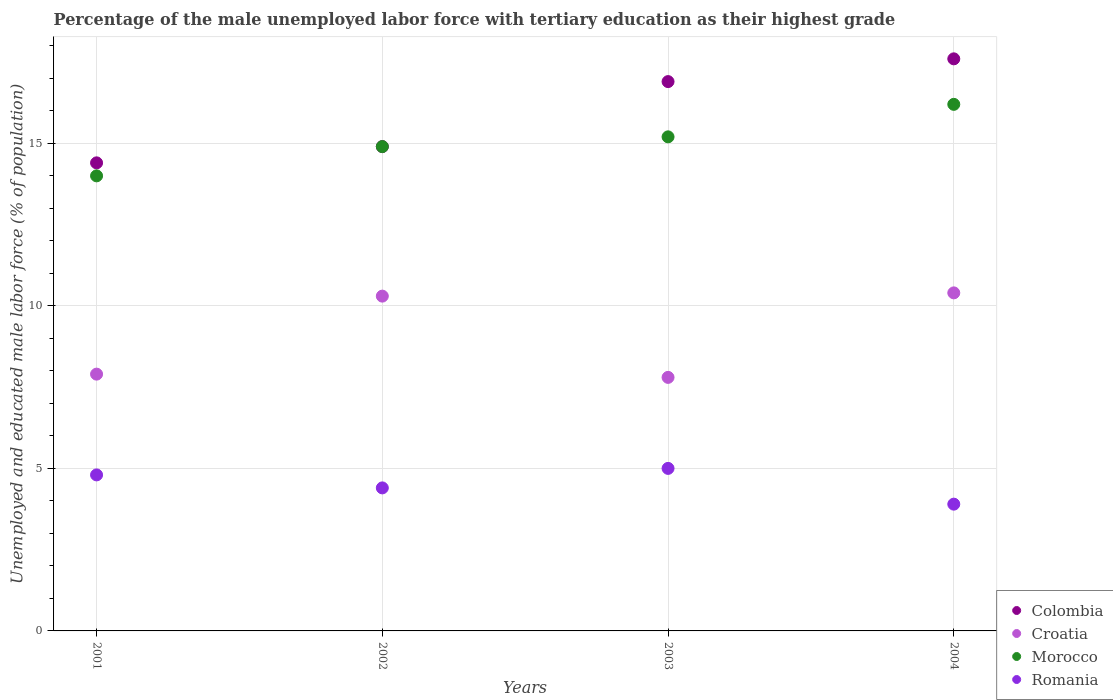Is the number of dotlines equal to the number of legend labels?
Give a very brief answer. Yes. What is the percentage of the unemployed male labor force with tertiary education in Morocco in 2001?
Ensure brevity in your answer.  14. Across all years, what is the maximum percentage of the unemployed male labor force with tertiary education in Colombia?
Give a very brief answer. 17.6. Across all years, what is the minimum percentage of the unemployed male labor force with tertiary education in Romania?
Your response must be concise. 3.9. What is the total percentage of the unemployed male labor force with tertiary education in Morocco in the graph?
Your response must be concise. 60.3. What is the difference between the percentage of the unemployed male labor force with tertiary education in Colombia in 2002 and that in 2004?
Provide a succinct answer. -2.7. What is the difference between the percentage of the unemployed male labor force with tertiary education in Morocco in 2002 and the percentage of the unemployed male labor force with tertiary education in Croatia in 2003?
Your answer should be very brief. 7.1. What is the average percentage of the unemployed male labor force with tertiary education in Romania per year?
Offer a very short reply. 4.53. In the year 2002, what is the difference between the percentage of the unemployed male labor force with tertiary education in Colombia and percentage of the unemployed male labor force with tertiary education in Croatia?
Give a very brief answer. 4.6. In how many years, is the percentage of the unemployed male labor force with tertiary education in Colombia greater than 11 %?
Your response must be concise. 4. What is the ratio of the percentage of the unemployed male labor force with tertiary education in Colombia in 2001 to that in 2003?
Make the answer very short. 0.85. Is the percentage of the unemployed male labor force with tertiary education in Morocco in 2001 less than that in 2002?
Provide a short and direct response. Yes. What is the difference between the highest and the second highest percentage of the unemployed male labor force with tertiary education in Romania?
Your response must be concise. 0.2. What is the difference between the highest and the lowest percentage of the unemployed male labor force with tertiary education in Colombia?
Ensure brevity in your answer.  3.2. In how many years, is the percentage of the unemployed male labor force with tertiary education in Colombia greater than the average percentage of the unemployed male labor force with tertiary education in Colombia taken over all years?
Provide a succinct answer. 2. Is it the case that in every year, the sum of the percentage of the unemployed male labor force with tertiary education in Colombia and percentage of the unemployed male labor force with tertiary education in Morocco  is greater than the sum of percentage of the unemployed male labor force with tertiary education in Croatia and percentage of the unemployed male labor force with tertiary education in Romania?
Ensure brevity in your answer.  Yes. How many dotlines are there?
Provide a short and direct response. 4. How many years are there in the graph?
Provide a short and direct response. 4. Does the graph contain any zero values?
Your answer should be very brief. No. Where does the legend appear in the graph?
Provide a succinct answer. Bottom right. How are the legend labels stacked?
Your response must be concise. Vertical. What is the title of the graph?
Keep it short and to the point. Percentage of the male unemployed labor force with tertiary education as their highest grade. What is the label or title of the Y-axis?
Your answer should be very brief. Unemployed and educated male labor force (% of population). What is the Unemployed and educated male labor force (% of population) of Colombia in 2001?
Your answer should be very brief. 14.4. What is the Unemployed and educated male labor force (% of population) of Croatia in 2001?
Provide a short and direct response. 7.9. What is the Unemployed and educated male labor force (% of population) of Morocco in 2001?
Provide a succinct answer. 14. What is the Unemployed and educated male labor force (% of population) of Romania in 2001?
Offer a terse response. 4.8. What is the Unemployed and educated male labor force (% of population) of Colombia in 2002?
Keep it short and to the point. 14.9. What is the Unemployed and educated male labor force (% of population) in Croatia in 2002?
Provide a succinct answer. 10.3. What is the Unemployed and educated male labor force (% of population) of Morocco in 2002?
Provide a succinct answer. 14.9. What is the Unemployed and educated male labor force (% of population) in Romania in 2002?
Offer a terse response. 4.4. What is the Unemployed and educated male labor force (% of population) of Colombia in 2003?
Your answer should be very brief. 16.9. What is the Unemployed and educated male labor force (% of population) of Croatia in 2003?
Give a very brief answer. 7.8. What is the Unemployed and educated male labor force (% of population) in Morocco in 2003?
Make the answer very short. 15.2. What is the Unemployed and educated male labor force (% of population) in Romania in 2003?
Offer a very short reply. 5. What is the Unemployed and educated male labor force (% of population) in Colombia in 2004?
Your answer should be very brief. 17.6. What is the Unemployed and educated male labor force (% of population) in Croatia in 2004?
Your answer should be compact. 10.4. What is the Unemployed and educated male labor force (% of population) of Morocco in 2004?
Give a very brief answer. 16.2. What is the Unemployed and educated male labor force (% of population) in Romania in 2004?
Ensure brevity in your answer.  3.9. Across all years, what is the maximum Unemployed and educated male labor force (% of population) of Colombia?
Your response must be concise. 17.6. Across all years, what is the maximum Unemployed and educated male labor force (% of population) in Croatia?
Provide a short and direct response. 10.4. Across all years, what is the maximum Unemployed and educated male labor force (% of population) in Morocco?
Keep it short and to the point. 16.2. Across all years, what is the maximum Unemployed and educated male labor force (% of population) of Romania?
Your answer should be very brief. 5. Across all years, what is the minimum Unemployed and educated male labor force (% of population) in Colombia?
Ensure brevity in your answer.  14.4. Across all years, what is the minimum Unemployed and educated male labor force (% of population) of Croatia?
Give a very brief answer. 7.8. Across all years, what is the minimum Unemployed and educated male labor force (% of population) of Morocco?
Keep it short and to the point. 14. Across all years, what is the minimum Unemployed and educated male labor force (% of population) of Romania?
Keep it short and to the point. 3.9. What is the total Unemployed and educated male labor force (% of population) in Colombia in the graph?
Give a very brief answer. 63.8. What is the total Unemployed and educated male labor force (% of population) of Croatia in the graph?
Your response must be concise. 36.4. What is the total Unemployed and educated male labor force (% of population) in Morocco in the graph?
Give a very brief answer. 60.3. What is the difference between the Unemployed and educated male labor force (% of population) in Morocco in 2001 and that in 2002?
Make the answer very short. -0.9. What is the difference between the Unemployed and educated male labor force (% of population) in Colombia in 2001 and that in 2003?
Give a very brief answer. -2.5. What is the difference between the Unemployed and educated male labor force (% of population) in Morocco in 2001 and that in 2003?
Give a very brief answer. -1.2. What is the difference between the Unemployed and educated male labor force (% of population) of Romania in 2001 and that in 2003?
Ensure brevity in your answer.  -0.2. What is the difference between the Unemployed and educated male labor force (% of population) in Colombia in 2001 and that in 2004?
Ensure brevity in your answer.  -3.2. What is the difference between the Unemployed and educated male labor force (% of population) of Croatia in 2001 and that in 2004?
Keep it short and to the point. -2.5. What is the difference between the Unemployed and educated male labor force (% of population) of Romania in 2001 and that in 2004?
Your response must be concise. 0.9. What is the difference between the Unemployed and educated male labor force (% of population) of Colombia in 2002 and that in 2003?
Offer a very short reply. -2. What is the difference between the Unemployed and educated male labor force (% of population) of Romania in 2002 and that in 2003?
Keep it short and to the point. -0.6. What is the difference between the Unemployed and educated male labor force (% of population) in Colombia in 2002 and that in 2004?
Give a very brief answer. -2.7. What is the difference between the Unemployed and educated male labor force (% of population) in Croatia in 2003 and that in 2004?
Ensure brevity in your answer.  -2.6. What is the difference between the Unemployed and educated male labor force (% of population) of Morocco in 2003 and that in 2004?
Offer a terse response. -1. What is the difference between the Unemployed and educated male labor force (% of population) of Romania in 2003 and that in 2004?
Your answer should be very brief. 1.1. What is the difference between the Unemployed and educated male labor force (% of population) of Colombia in 2001 and the Unemployed and educated male labor force (% of population) of Croatia in 2002?
Your answer should be very brief. 4.1. What is the difference between the Unemployed and educated male labor force (% of population) of Colombia in 2001 and the Unemployed and educated male labor force (% of population) of Romania in 2002?
Your answer should be very brief. 10. What is the difference between the Unemployed and educated male labor force (% of population) of Croatia in 2001 and the Unemployed and educated male labor force (% of population) of Morocco in 2002?
Ensure brevity in your answer.  -7. What is the difference between the Unemployed and educated male labor force (% of population) in Colombia in 2001 and the Unemployed and educated male labor force (% of population) in Morocco in 2003?
Make the answer very short. -0.8. What is the difference between the Unemployed and educated male labor force (% of population) of Croatia in 2001 and the Unemployed and educated male labor force (% of population) of Morocco in 2003?
Offer a very short reply. -7.3. What is the difference between the Unemployed and educated male labor force (% of population) of Croatia in 2001 and the Unemployed and educated male labor force (% of population) of Romania in 2003?
Offer a very short reply. 2.9. What is the difference between the Unemployed and educated male labor force (% of population) in Colombia in 2001 and the Unemployed and educated male labor force (% of population) in Morocco in 2004?
Make the answer very short. -1.8. What is the difference between the Unemployed and educated male labor force (% of population) of Croatia in 2001 and the Unemployed and educated male labor force (% of population) of Morocco in 2004?
Give a very brief answer. -8.3. What is the difference between the Unemployed and educated male labor force (% of population) in Morocco in 2001 and the Unemployed and educated male labor force (% of population) in Romania in 2004?
Your answer should be very brief. 10.1. What is the difference between the Unemployed and educated male labor force (% of population) in Colombia in 2002 and the Unemployed and educated male labor force (% of population) in Morocco in 2003?
Your response must be concise. -0.3. What is the difference between the Unemployed and educated male labor force (% of population) in Croatia in 2002 and the Unemployed and educated male labor force (% of population) in Romania in 2003?
Your response must be concise. 5.3. What is the difference between the Unemployed and educated male labor force (% of population) of Colombia in 2002 and the Unemployed and educated male labor force (% of population) of Croatia in 2004?
Give a very brief answer. 4.5. What is the difference between the Unemployed and educated male labor force (% of population) in Colombia in 2002 and the Unemployed and educated male labor force (% of population) in Morocco in 2004?
Provide a short and direct response. -1.3. What is the difference between the Unemployed and educated male labor force (% of population) of Colombia in 2002 and the Unemployed and educated male labor force (% of population) of Romania in 2004?
Offer a very short reply. 11. What is the difference between the Unemployed and educated male labor force (% of population) in Croatia in 2002 and the Unemployed and educated male labor force (% of population) in Morocco in 2004?
Your answer should be compact. -5.9. What is the difference between the Unemployed and educated male labor force (% of population) of Croatia in 2002 and the Unemployed and educated male labor force (% of population) of Romania in 2004?
Your response must be concise. 6.4. What is the difference between the Unemployed and educated male labor force (% of population) of Croatia in 2003 and the Unemployed and educated male labor force (% of population) of Morocco in 2004?
Offer a terse response. -8.4. What is the difference between the Unemployed and educated male labor force (% of population) of Morocco in 2003 and the Unemployed and educated male labor force (% of population) of Romania in 2004?
Offer a very short reply. 11.3. What is the average Unemployed and educated male labor force (% of population) in Colombia per year?
Give a very brief answer. 15.95. What is the average Unemployed and educated male labor force (% of population) of Morocco per year?
Keep it short and to the point. 15.07. What is the average Unemployed and educated male labor force (% of population) in Romania per year?
Your answer should be compact. 4.53. In the year 2001, what is the difference between the Unemployed and educated male labor force (% of population) in Colombia and Unemployed and educated male labor force (% of population) in Romania?
Your answer should be very brief. 9.6. In the year 2001, what is the difference between the Unemployed and educated male labor force (% of population) in Croatia and Unemployed and educated male labor force (% of population) in Morocco?
Keep it short and to the point. -6.1. In the year 2001, what is the difference between the Unemployed and educated male labor force (% of population) in Morocco and Unemployed and educated male labor force (% of population) in Romania?
Ensure brevity in your answer.  9.2. In the year 2002, what is the difference between the Unemployed and educated male labor force (% of population) of Colombia and Unemployed and educated male labor force (% of population) of Morocco?
Provide a short and direct response. 0. In the year 2002, what is the difference between the Unemployed and educated male labor force (% of population) of Colombia and Unemployed and educated male labor force (% of population) of Romania?
Give a very brief answer. 10.5. In the year 2002, what is the difference between the Unemployed and educated male labor force (% of population) of Morocco and Unemployed and educated male labor force (% of population) of Romania?
Keep it short and to the point. 10.5. In the year 2003, what is the difference between the Unemployed and educated male labor force (% of population) of Colombia and Unemployed and educated male labor force (% of population) of Morocco?
Your answer should be compact. 1.7. In the year 2003, what is the difference between the Unemployed and educated male labor force (% of population) of Croatia and Unemployed and educated male labor force (% of population) of Morocco?
Give a very brief answer. -7.4. In the year 2003, what is the difference between the Unemployed and educated male labor force (% of population) of Croatia and Unemployed and educated male labor force (% of population) of Romania?
Offer a very short reply. 2.8. In the year 2004, what is the difference between the Unemployed and educated male labor force (% of population) in Morocco and Unemployed and educated male labor force (% of population) in Romania?
Give a very brief answer. 12.3. What is the ratio of the Unemployed and educated male labor force (% of population) of Colombia in 2001 to that in 2002?
Give a very brief answer. 0.97. What is the ratio of the Unemployed and educated male labor force (% of population) in Croatia in 2001 to that in 2002?
Ensure brevity in your answer.  0.77. What is the ratio of the Unemployed and educated male labor force (% of population) of Morocco in 2001 to that in 2002?
Make the answer very short. 0.94. What is the ratio of the Unemployed and educated male labor force (% of population) in Colombia in 2001 to that in 2003?
Offer a very short reply. 0.85. What is the ratio of the Unemployed and educated male labor force (% of population) in Croatia in 2001 to that in 2003?
Provide a succinct answer. 1.01. What is the ratio of the Unemployed and educated male labor force (% of population) of Morocco in 2001 to that in 2003?
Make the answer very short. 0.92. What is the ratio of the Unemployed and educated male labor force (% of population) in Colombia in 2001 to that in 2004?
Offer a very short reply. 0.82. What is the ratio of the Unemployed and educated male labor force (% of population) of Croatia in 2001 to that in 2004?
Keep it short and to the point. 0.76. What is the ratio of the Unemployed and educated male labor force (% of population) in Morocco in 2001 to that in 2004?
Keep it short and to the point. 0.86. What is the ratio of the Unemployed and educated male labor force (% of population) of Romania in 2001 to that in 2004?
Offer a very short reply. 1.23. What is the ratio of the Unemployed and educated male labor force (% of population) in Colombia in 2002 to that in 2003?
Your response must be concise. 0.88. What is the ratio of the Unemployed and educated male labor force (% of population) of Croatia in 2002 to that in 2003?
Make the answer very short. 1.32. What is the ratio of the Unemployed and educated male labor force (% of population) of Morocco in 2002 to that in 2003?
Keep it short and to the point. 0.98. What is the ratio of the Unemployed and educated male labor force (% of population) of Romania in 2002 to that in 2003?
Your answer should be very brief. 0.88. What is the ratio of the Unemployed and educated male labor force (% of population) in Colombia in 2002 to that in 2004?
Keep it short and to the point. 0.85. What is the ratio of the Unemployed and educated male labor force (% of population) of Croatia in 2002 to that in 2004?
Make the answer very short. 0.99. What is the ratio of the Unemployed and educated male labor force (% of population) of Morocco in 2002 to that in 2004?
Provide a succinct answer. 0.92. What is the ratio of the Unemployed and educated male labor force (% of population) of Romania in 2002 to that in 2004?
Your answer should be compact. 1.13. What is the ratio of the Unemployed and educated male labor force (% of population) in Colombia in 2003 to that in 2004?
Give a very brief answer. 0.96. What is the ratio of the Unemployed and educated male labor force (% of population) in Morocco in 2003 to that in 2004?
Your response must be concise. 0.94. What is the ratio of the Unemployed and educated male labor force (% of population) in Romania in 2003 to that in 2004?
Offer a very short reply. 1.28. What is the difference between the highest and the second highest Unemployed and educated male labor force (% of population) in Colombia?
Give a very brief answer. 0.7. What is the difference between the highest and the second highest Unemployed and educated male labor force (% of population) in Romania?
Your answer should be very brief. 0.2. 